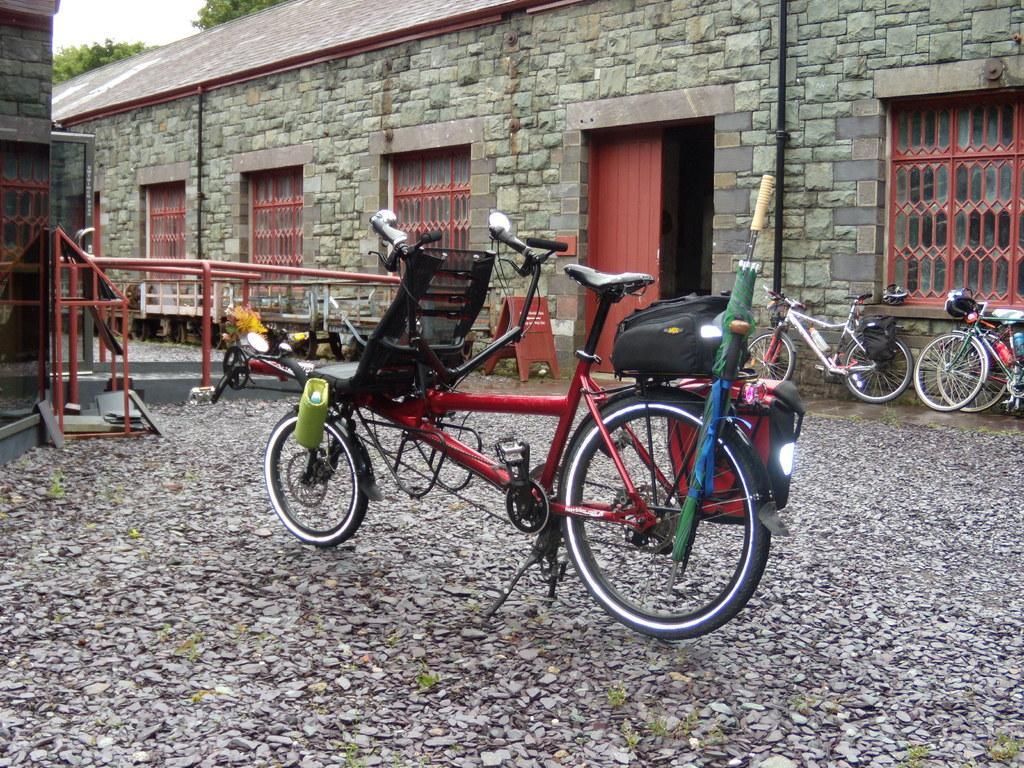Please provide a concise description of this image. In this picture there are few bicycles which has few objects placed on it and there is a rock building which has red color doors and windows and there is another building in the left corner. 